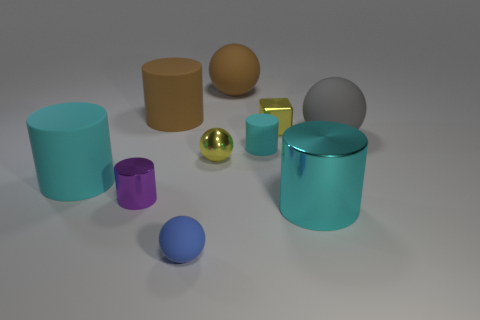What is the material of the yellow ball that is in front of the brown thing that is on the left side of the yellow shiny sphere? The yellow ball appears to be made of a matte material, such as rubber or plastic, contrasting with the shiny metallic surface of the sphere to its right. 